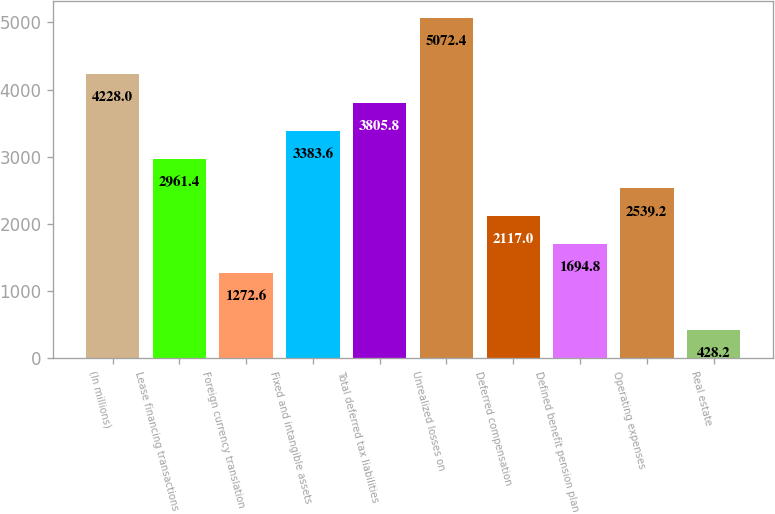<chart> <loc_0><loc_0><loc_500><loc_500><bar_chart><fcel>(In millions)<fcel>Lease financing transactions<fcel>Foreign currency translation<fcel>Fixed and intangible assets<fcel>Total deferred tax liabilities<fcel>Unrealized losses on<fcel>Deferred compensation<fcel>Defined benefit pension plan<fcel>Operating expenses<fcel>Real estate<nl><fcel>4228<fcel>2961.4<fcel>1272.6<fcel>3383.6<fcel>3805.8<fcel>5072.4<fcel>2117<fcel>1694.8<fcel>2539.2<fcel>428.2<nl></chart> 